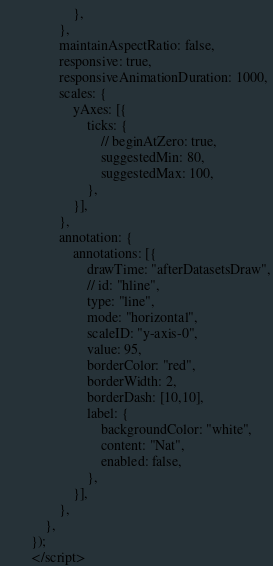<code> <loc_0><loc_0><loc_500><loc_500><_PHP_>                    },
                },
                maintainAspectRatio: false,
                responsive: true,
                responsiveAnimationDuration: 1000,
                scales: {
                    yAxes: [{
                        ticks: {
                            // beginAtZero: true,
                            suggestedMin: 80,
                            suggestedMax: 100,
                        },
                    }],
                },
                annotation: {
                    annotations: [{
                        drawTime: "afterDatasetsDraw",
                        // id: "hline",
                        type: "line",
                        mode: "horizontal",
                        scaleID: "y-axis-0",
                        value: 95,
                        borderColor: "red",
                        borderWidth: 2,
                        borderDash: [10,10],
                        label: {
                            backgroundColor: "white",
                            content: "Nat",
                            enabled: false,
                        },
                    }],
                },
            },
        });
        </script>

</code> 